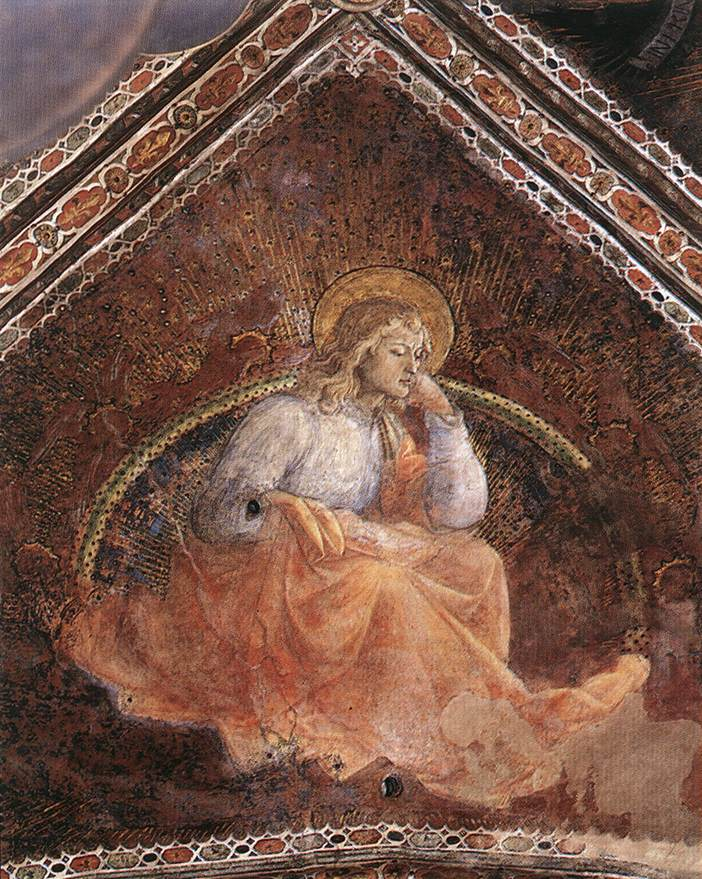Write a detailed description of the given image. The image portrays an angel in a contemplative pose, suggesting deep thought or meditation. The angel is clothed in a white robe that signifies purity and innocence, enhanced by the presence of a golden halo above its head, a traditional emblem of holiness and divinity. The angel’s wings add to its celestial nature with gentle, delicate hues. The background is a striking contrast with the angel’s brightness; it is richly painted in a dark, almost crimson red with intricate golden accents, lending a sense of depth and opulence to the overall scene. The artistic style is reminiscent of the Renaissance period, known for its meticulous attention to detail, realistic portrayal of subjects, and use of symbolic imagery. The genre is unmistakably religious, highlighted by the angelic figure and the thoughtful use of color and elements to convey a sense of divine presence and introspection. 